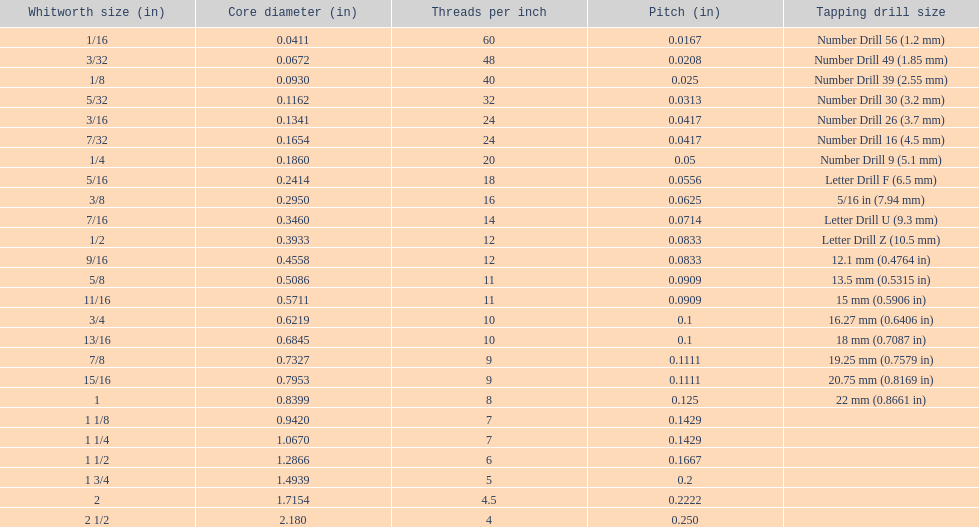In which whitworth size can you find exactly 5 threads per inch? 1 3/4. 